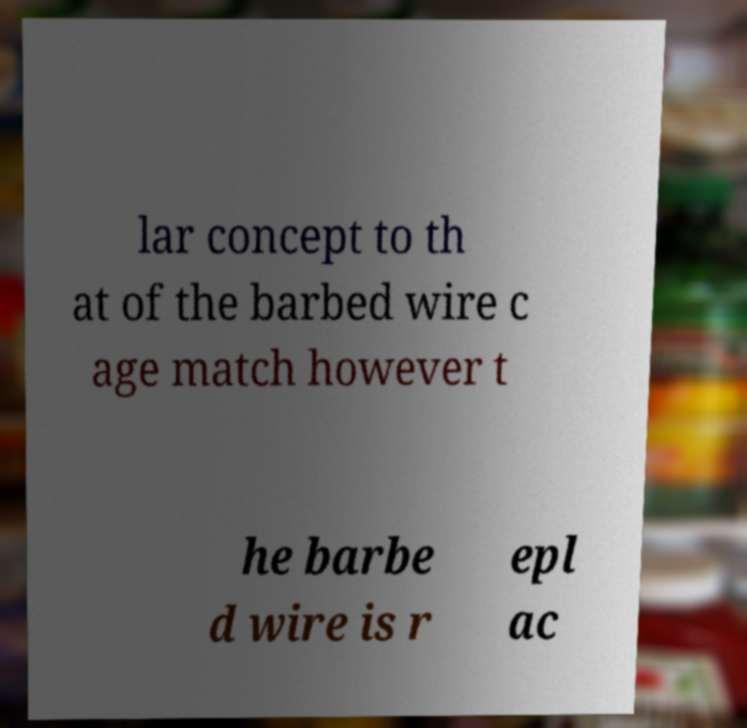Can you accurately transcribe the text from the provided image for me? lar concept to th at of the barbed wire c age match however t he barbe d wire is r epl ac 